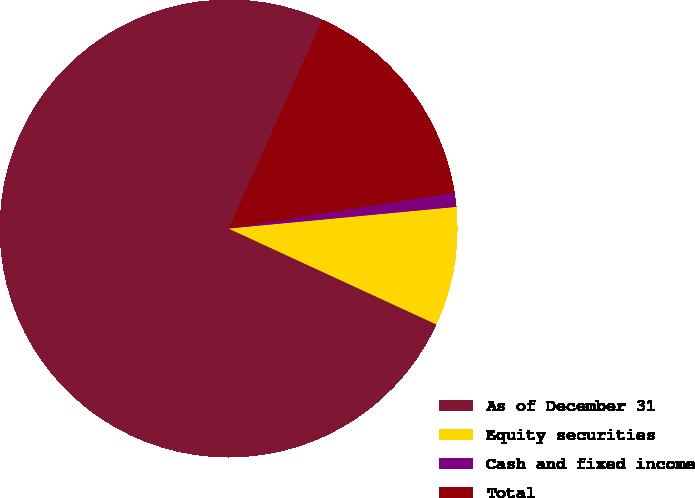Convert chart to OTSL. <chart><loc_0><loc_0><loc_500><loc_500><pie_chart><fcel>As of December 31<fcel>Equity securities<fcel>Cash and fixed income<fcel>Total<nl><fcel>74.84%<fcel>8.39%<fcel>1.0%<fcel>15.77%<nl></chart> 